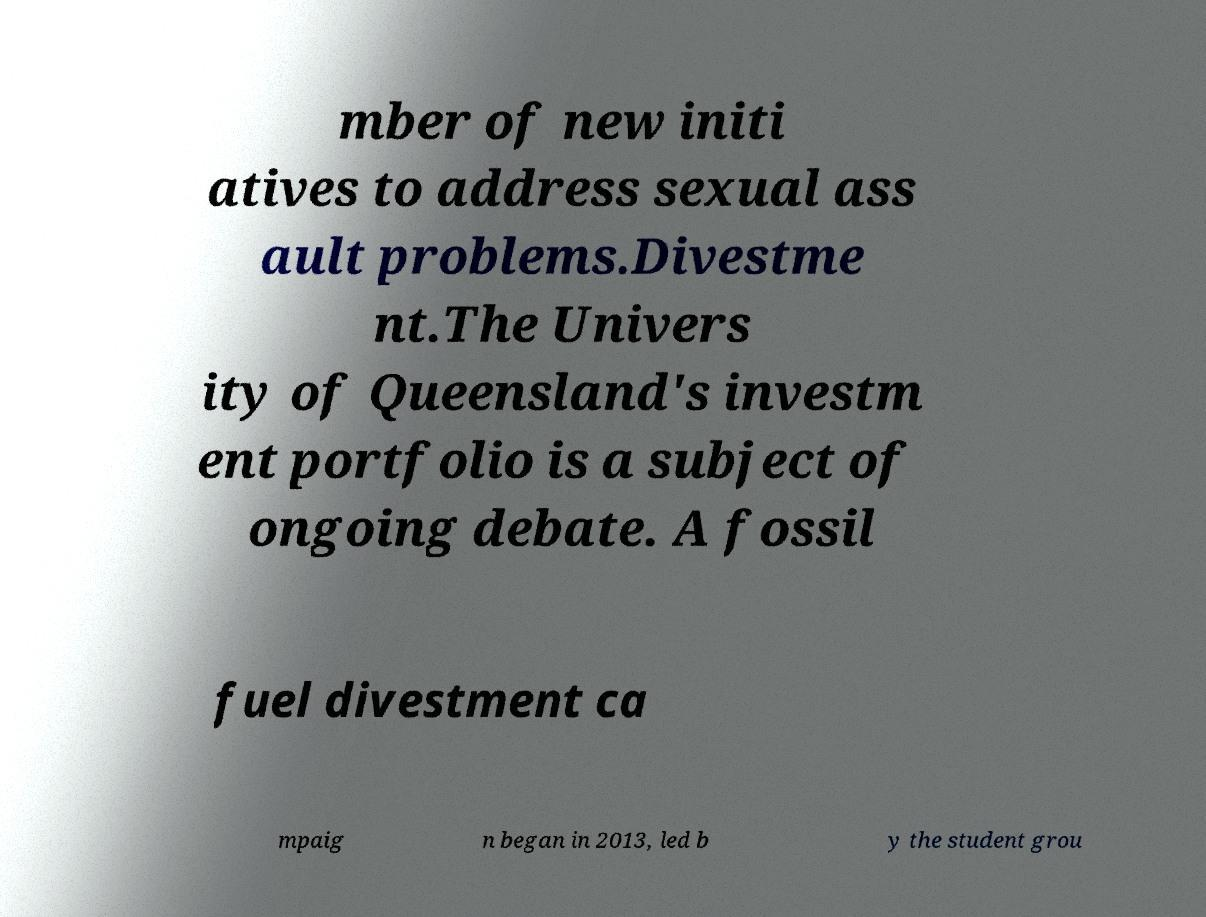Please read and relay the text visible in this image. What does it say? mber of new initi atives to address sexual ass ault problems.Divestme nt.The Univers ity of Queensland's investm ent portfolio is a subject of ongoing debate. A fossil fuel divestment ca mpaig n began in 2013, led b y the student grou 